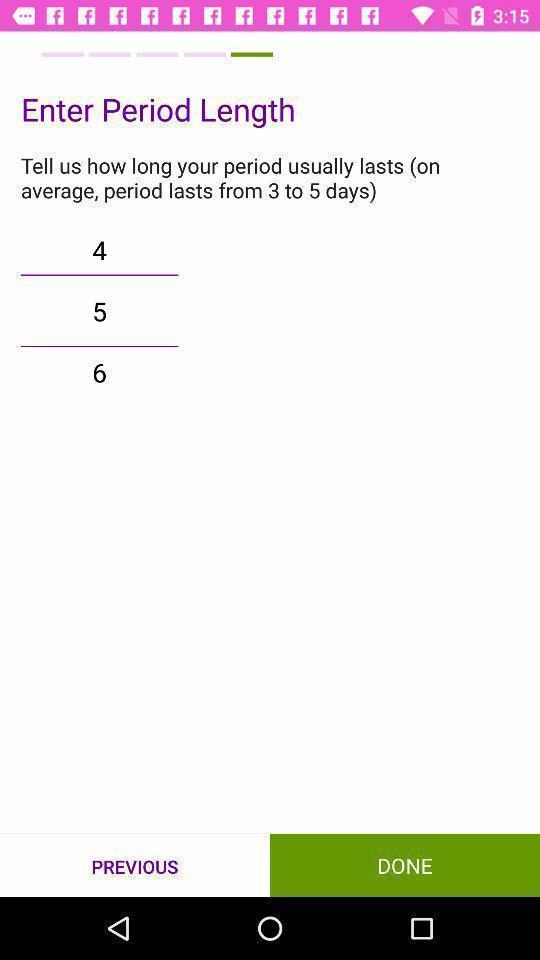Describe the key features of this screenshot. Screen display average period days in health app. 